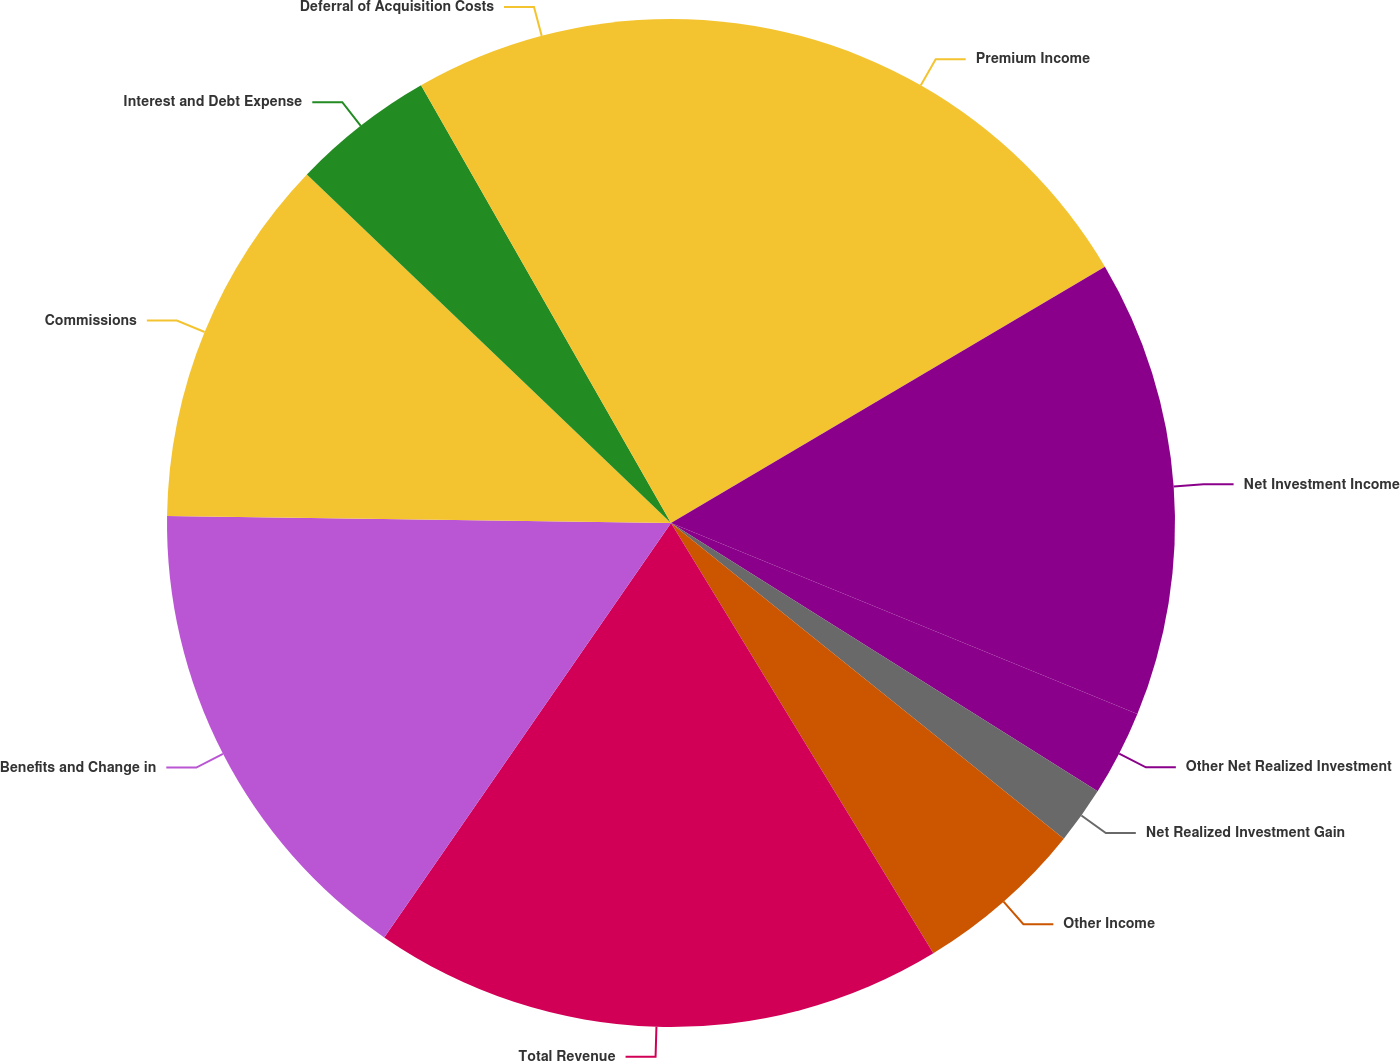<chart> <loc_0><loc_0><loc_500><loc_500><pie_chart><fcel>Premium Income<fcel>Net Investment Income<fcel>Other Net Realized Investment<fcel>Net Realized Investment Gain<fcel>Other Income<fcel>Total Revenue<fcel>Benefits and Change in<fcel>Commissions<fcel>Interest and Debt Expense<fcel>Deferral of Acquisition Costs<nl><fcel>16.51%<fcel>14.68%<fcel>2.75%<fcel>1.84%<fcel>5.51%<fcel>18.35%<fcel>15.59%<fcel>11.93%<fcel>4.59%<fcel>8.26%<nl></chart> 